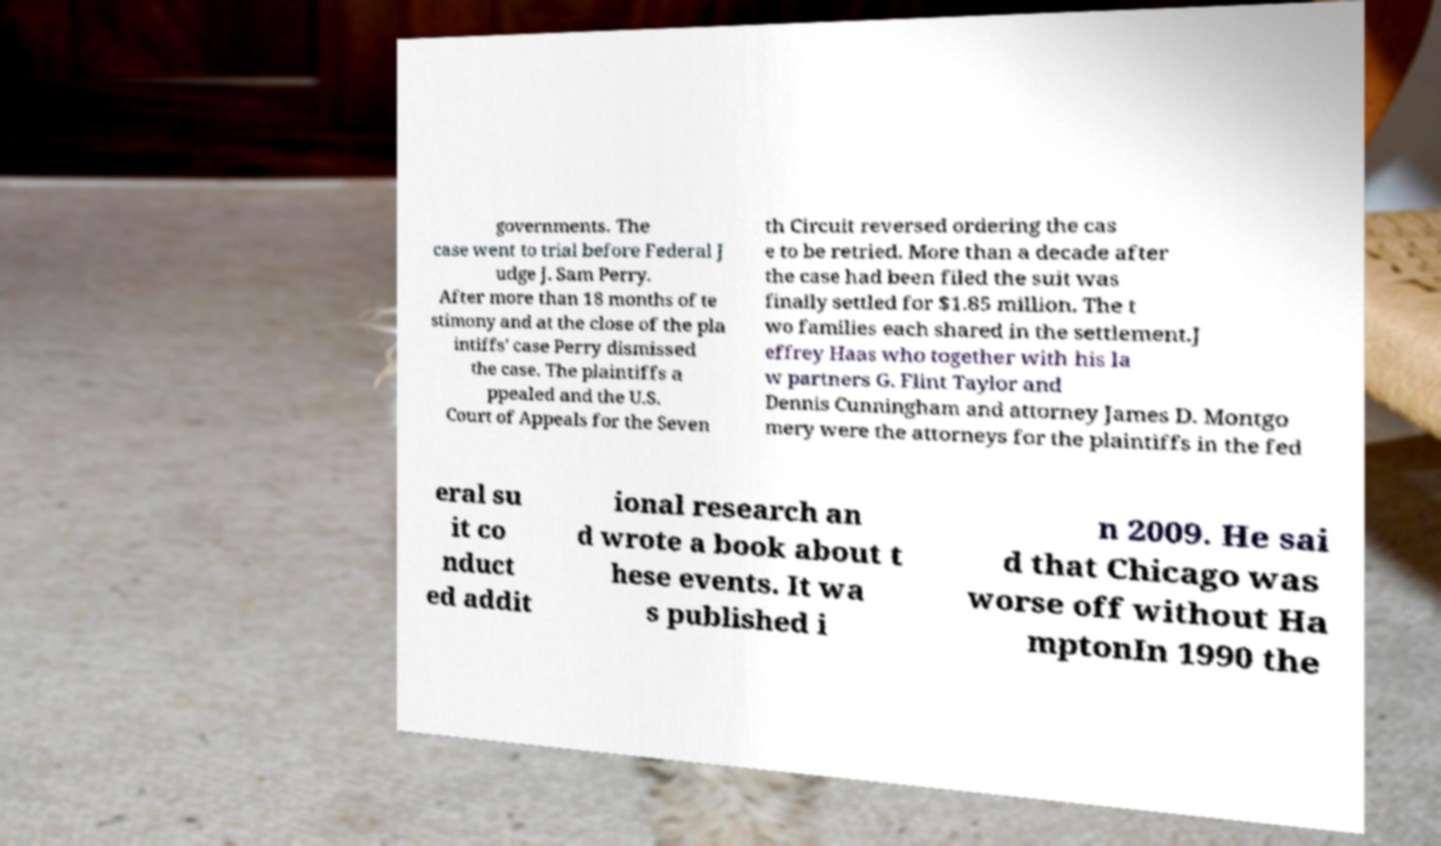There's text embedded in this image that I need extracted. Can you transcribe it verbatim? governments. The case went to trial before Federal J udge J. Sam Perry. After more than 18 months of te stimony and at the close of the pla intiffs' case Perry dismissed the case. The plaintiffs a ppealed and the U.S. Court of Appeals for the Seven th Circuit reversed ordering the cas e to be retried. More than a decade after the case had been filed the suit was finally settled for $1.85 million. The t wo families each shared in the settlement.J effrey Haas who together with his la w partners G. Flint Taylor and Dennis Cunningham and attorney James D. Montgo mery were the attorneys for the plaintiffs in the fed eral su it co nduct ed addit ional research an d wrote a book about t hese events. It wa s published i n 2009. He sai d that Chicago was worse off without Ha mptonIn 1990 the 